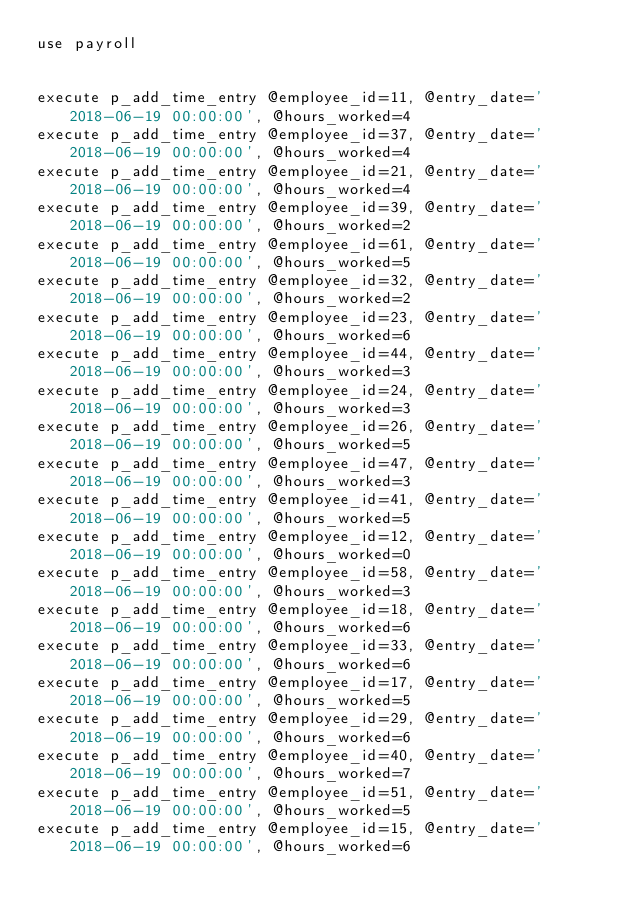Convert code to text. <code><loc_0><loc_0><loc_500><loc_500><_SQL_>use payroll


execute p_add_time_entry @employee_id=11, @entry_date='2018-06-19 00:00:00', @hours_worked=4
execute p_add_time_entry @employee_id=37, @entry_date='2018-06-19 00:00:00', @hours_worked=4
execute p_add_time_entry @employee_id=21, @entry_date='2018-06-19 00:00:00', @hours_worked=4
execute p_add_time_entry @employee_id=39, @entry_date='2018-06-19 00:00:00', @hours_worked=2
execute p_add_time_entry @employee_id=61, @entry_date='2018-06-19 00:00:00', @hours_worked=5
execute p_add_time_entry @employee_id=32, @entry_date='2018-06-19 00:00:00', @hours_worked=2
execute p_add_time_entry @employee_id=23, @entry_date='2018-06-19 00:00:00', @hours_worked=6
execute p_add_time_entry @employee_id=44, @entry_date='2018-06-19 00:00:00', @hours_worked=3
execute p_add_time_entry @employee_id=24, @entry_date='2018-06-19 00:00:00', @hours_worked=3
execute p_add_time_entry @employee_id=26, @entry_date='2018-06-19 00:00:00', @hours_worked=5
execute p_add_time_entry @employee_id=47, @entry_date='2018-06-19 00:00:00', @hours_worked=3
execute p_add_time_entry @employee_id=41, @entry_date='2018-06-19 00:00:00', @hours_worked=5
execute p_add_time_entry @employee_id=12, @entry_date='2018-06-19 00:00:00', @hours_worked=0
execute p_add_time_entry @employee_id=58, @entry_date='2018-06-19 00:00:00', @hours_worked=3
execute p_add_time_entry @employee_id=18, @entry_date='2018-06-19 00:00:00', @hours_worked=6
execute p_add_time_entry @employee_id=33, @entry_date='2018-06-19 00:00:00', @hours_worked=6
execute p_add_time_entry @employee_id=17, @entry_date='2018-06-19 00:00:00', @hours_worked=5
execute p_add_time_entry @employee_id=29, @entry_date='2018-06-19 00:00:00', @hours_worked=6
execute p_add_time_entry @employee_id=40, @entry_date='2018-06-19 00:00:00', @hours_worked=7
execute p_add_time_entry @employee_id=51, @entry_date='2018-06-19 00:00:00', @hours_worked=5
execute p_add_time_entry @employee_id=15, @entry_date='2018-06-19 00:00:00', @hours_worked=6

</code> 